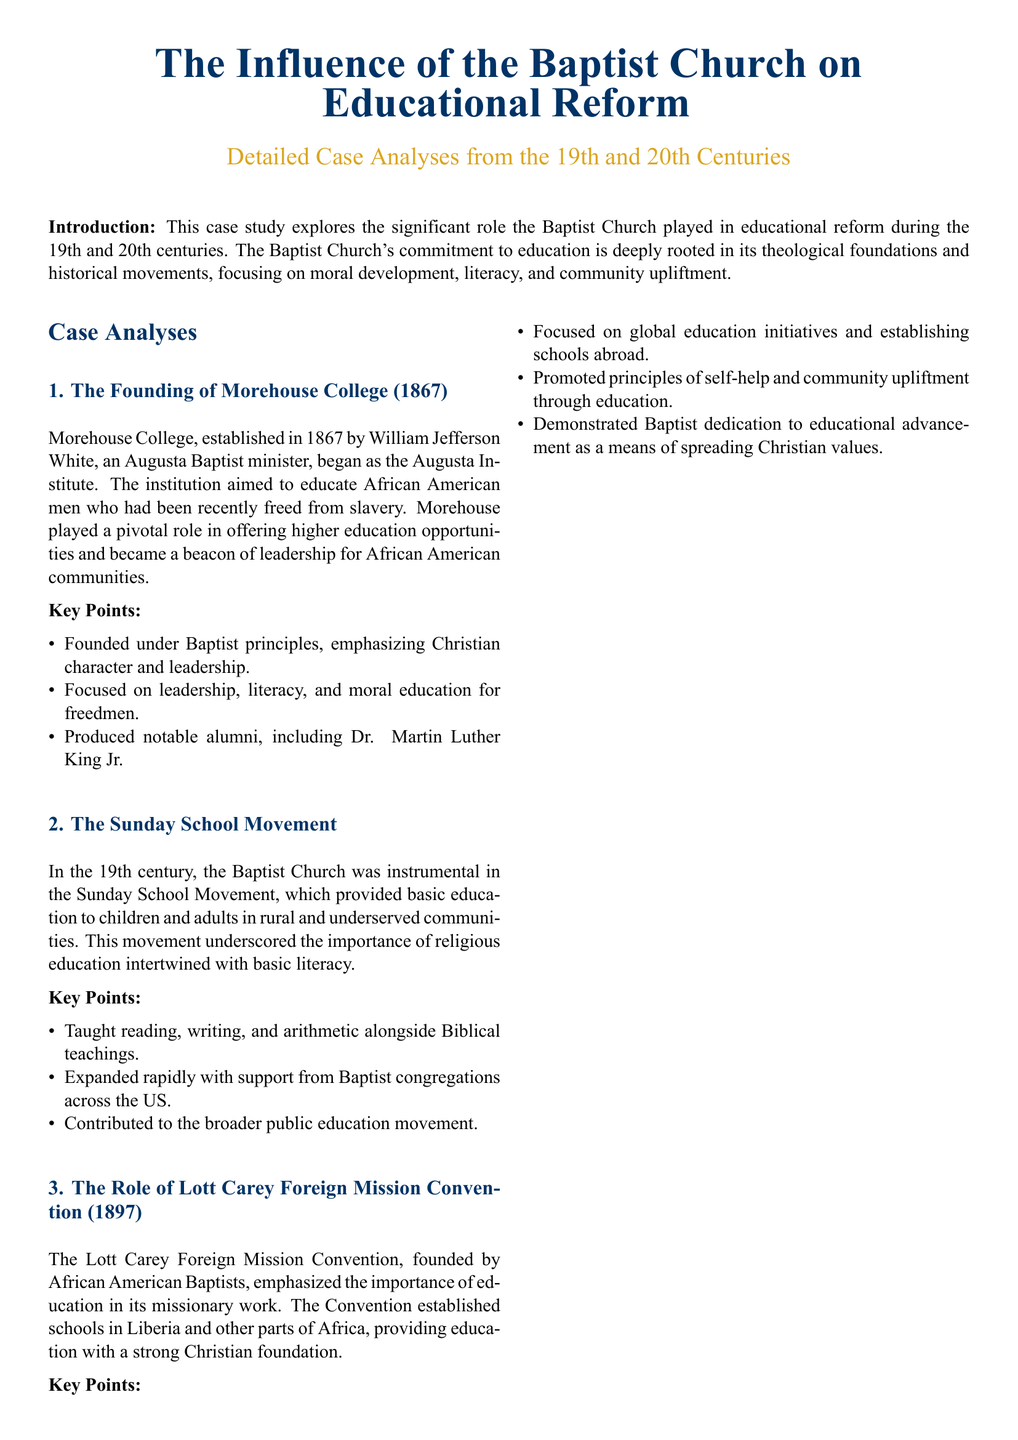What year was Morehouse College founded? Morehouse College was established in 1867, according to the case analysis presented in the document.
Answer: 1867 Who founded Morehouse College? The document states that Morehouse College was founded by William Jefferson White, an Augusta Baptist minister.
Answer: William Jefferson White What was the initial name of Morehouse College? The document mentions that Morehouse College began as the Augusta Institute before it took its current name.
Answer: Augusta Institute What movement did the Baptist Church support in the 19th century for education? The Sunday School Movement is highlighted in the document as a significant educational initiative supported by the Baptist Church.
Answer: Sunday School Movement What key educational focus did the Sunday School Movement emphasize? The document indicates that the Sunday School Movement taught reading, writing, and arithmetic alongside Biblical teachings.
Answer: Reading, writing, and arithmetic In what year was the Lott Carey Foreign Mission Convention established? The document specifies that the Lott Carey Foreign Mission Convention was founded in 1897.
Answer: 1897 What was one of the goals of the Lott Carey Foreign Mission Convention? The document states that one of the goals was to establish schools in Liberia and other parts of Africa.
Answer: Establishing schools Who is a notable alumnus of Morehouse College? According to the document, Dr. Martin Luther King Jr. is mentioned as a notable alumnus of Morehouse College.
Answer: Dr. Martin Luther King Jr What was a key principle promoted by the Lott Carey Foreign Mission Convention? The document reveals that the Convention promoted the principle of self-help through education in its missionary work.
Answer: Self-help 